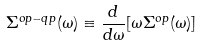<formula> <loc_0><loc_0><loc_500><loc_500>\Sigma ^ { o p - q p } ( \omega ) \equiv \frac { d } { d \omega } [ \omega \Sigma ^ { o p } ( \omega ) ]</formula> 